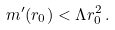Convert formula to latex. <formula><loc_0><loc_0><loc_500><loc_500>m ^ { \prime } ( r _ { 0 } ) < \Lambda r _ { 0 } ^ { 2 } \, .</formula> 